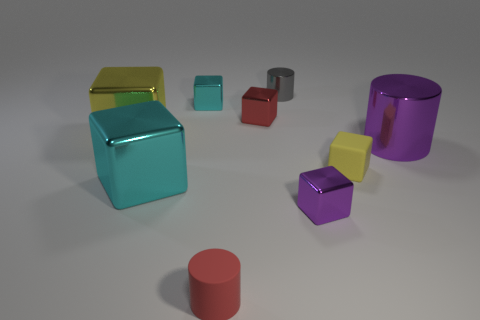Subtract all small matte blocks. How many blocks are left? 5 Subtract all purple cubes. How many cubes are left? 5 Subtract all gray blocks. Subtract all yellow cylinders. How many blocks are left? 6 Subtract all cylinders. How many objects are left? 6 Add 2 small objects. How many small objects exist? 8 Subtract 0 cyan spheres. How many objects are left? 9 Subtract all small red cubes. Subtract all small cyan shiny things. How many objects are left? 7 Add 1 small purple metallic objects. How many small purple metallic objects are left? 2 